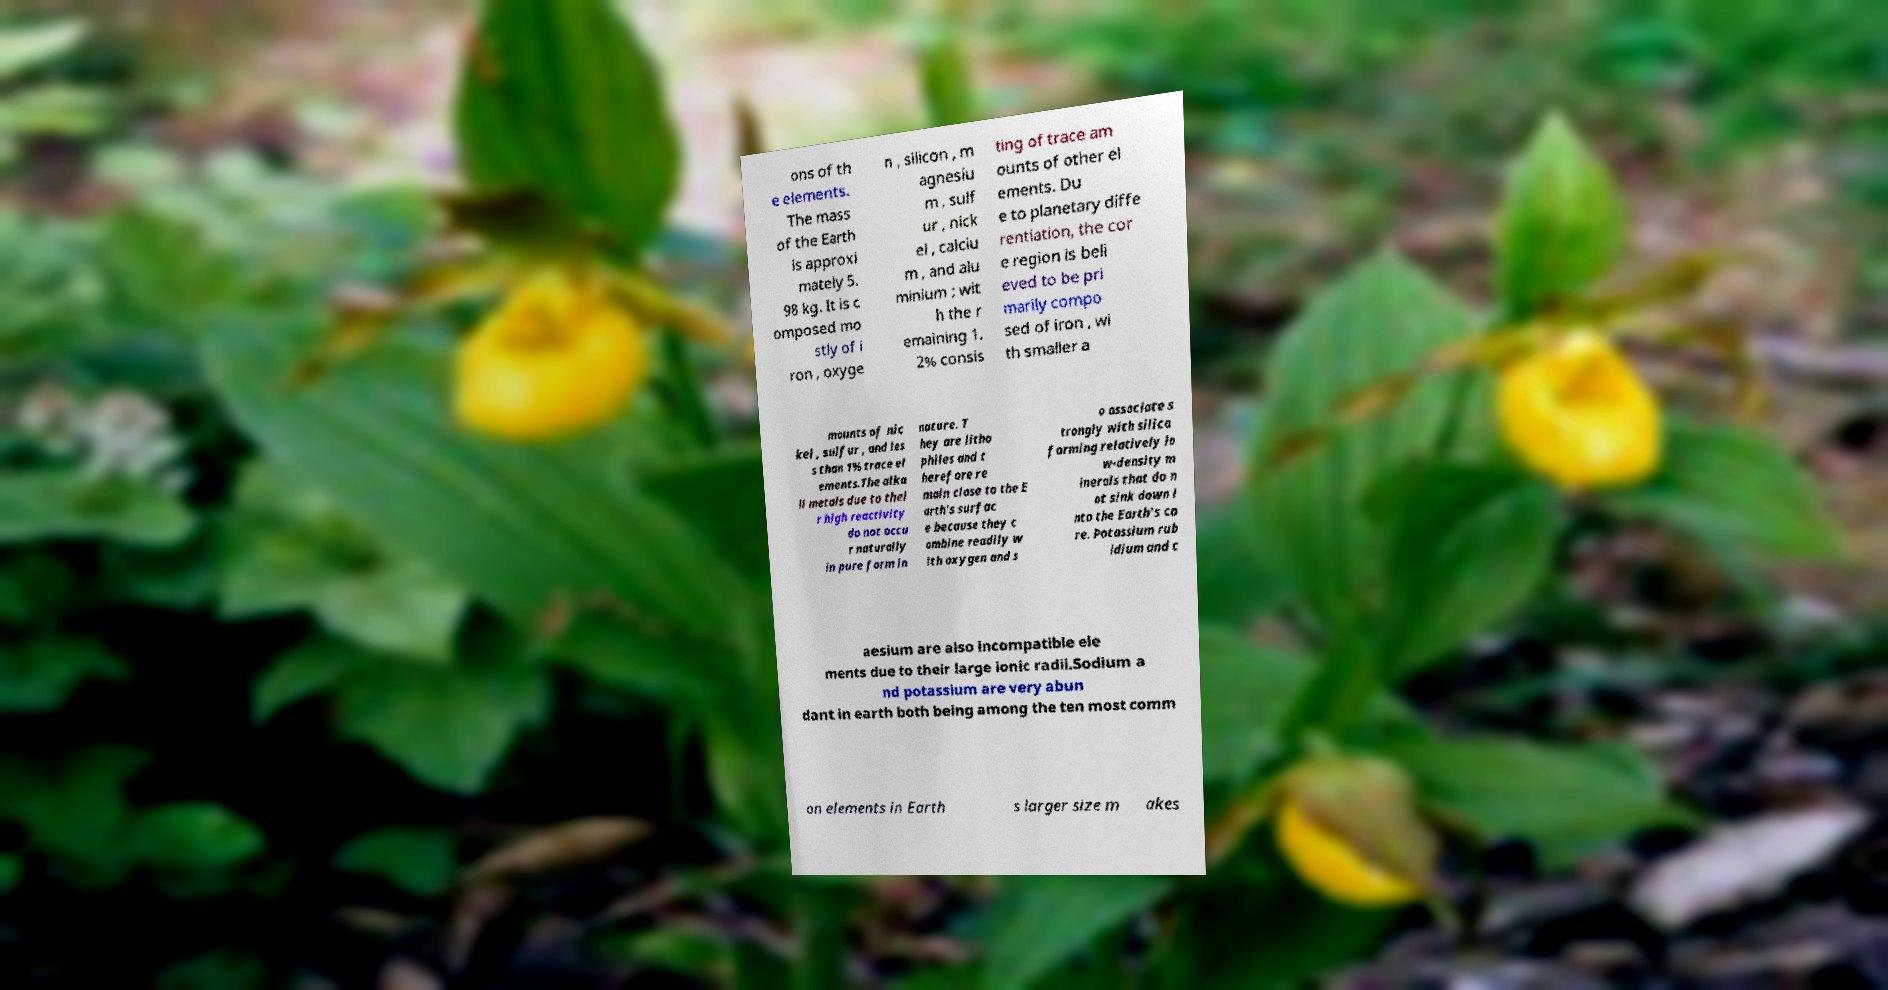Could you extract and type out the text from this image? ons of th e elements. The mass of the Earth is approxi mately 5. 98 kg. It is c omposed mo stly of i ron , oxyge n , silicon , m agnesiu m , sulf ur , nick el , calciu m , and alu minium ; wit h the r emaining 1. 2% consis ting of trace am ounts of other el ements. Du e to planetary diffe rentiation, the cor e region is beli eved to be pri marily compo sed of iron , wi th smaller a mounts of nic kel , sulfur , and les s than 1% trace el ements.The alka li metals due to thei r high reactivity do not occu r naturally in pure form in nature. T hey are litho philes and t herefore re main close to the E arth's surfac e because they c ombine readily w ith oxygen and s o associate s trongly with silica forming relatively lo w-density m inerals that do n ot sink down i nto the Earth's co re. Potassium rub idium and c aesium are also incompatible ele ments due to their large ionic radii.Sodium a nd potassium are very abun dant in earth both being among the ten most comm on elements in Earth s larger size m akes 